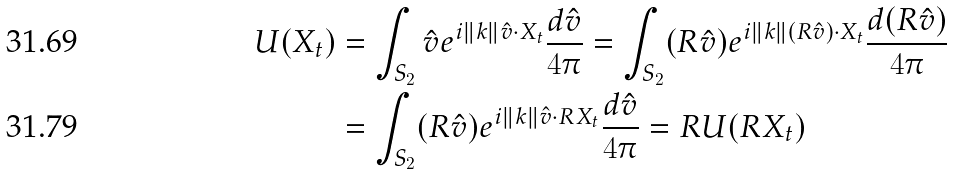<formula> <loc_0><loc_0><loc_500><loc_500>U ( X _ { t } ) & = \int _ { S _ { 2 } } \hat { v } e ^ { i \| k \| \hat { v } \cdot X _ { t } } \frac { d \hat { v } } { 4 \pi } = \int _ { S _ { 2 } } ( R \hat { v } ) e ^ { i \| k \| ( R \hat { v } ) \cdot X _ { t } } \frac { d ( R \hat { v } ) } { 4 \pi } \\ & = \int _ { S _ { 2 } } ( R \hat { v } ) e ^ { i \| k \| \hat { v } \cdot R X _ { t } } \frac { d \hat { v } } { 4 \pi } = R U ( R X _ { t } )</formula> 